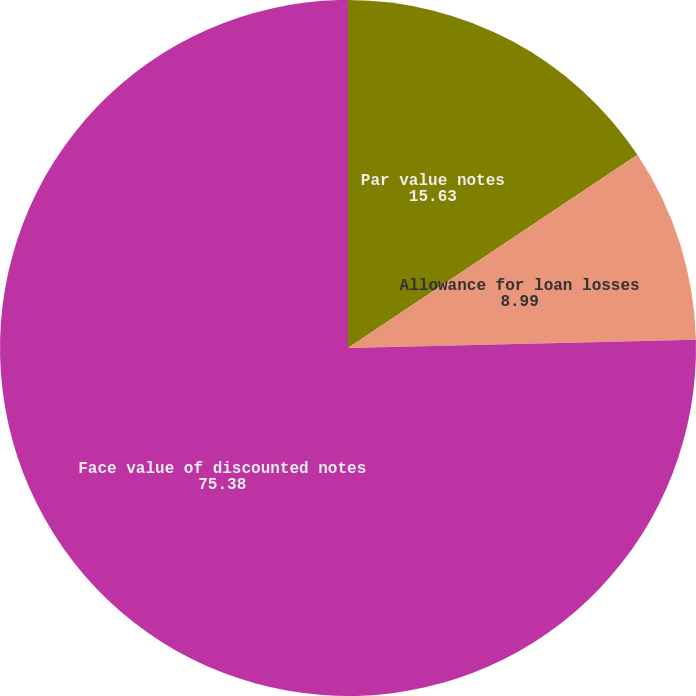<chart> <loc_0><loc_0><loc_500><loc_500><pie_chart><fcel>Par value notes<fcel>Allowance for loan losses<fcel>Face value of discounted notes<nl><fcel>15.63%<fcel>8.99%<fcel>75.38%<nl></chart> 